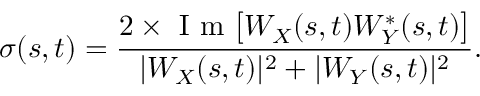Convert formula to latex. <formula><loc_0><loc_0><loc_500><loc_500>\sigma ( s , t ) = \frac { 2 \times I m \left [ W _ { X } ( s , t ) W _ { Y } ^ { * } ( s , t ) \right ] } { | W _ { X } ( s , t ) | ^ { 2 } + | W _ { Y } ( s , t ) | ^ { 2 } } .</formula> 